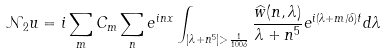Convert formula to latex. <formula><loc_0><loc_0><loc_500><loc_500>\mathcal { N } _ { 2 } u = i \sum _ { m } C _ { m } \sum _ { n } e ^ { i n x } \int _ { | \lambda + n ^ { 5 } | > \frac { 1 } { 1 0 0 \delta } } \frac { \widehat { w } ( n , \lambda ) } { \lambda + n ^ { 5 } } e ^ { i ( \lambda + m / \delta ) t } d \lambda</formula> 